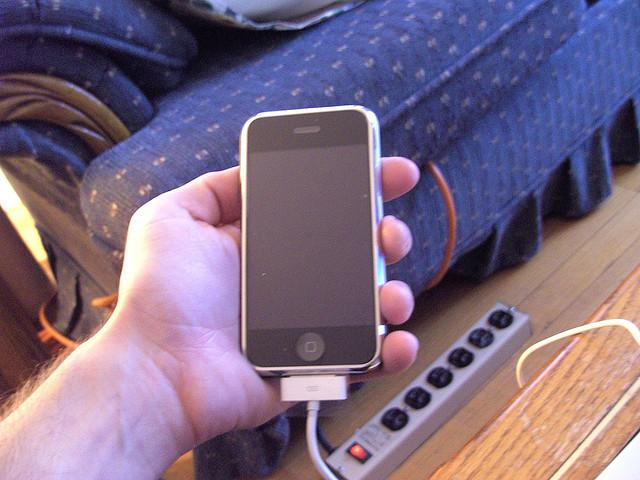What is the item on the floor called? power strip 